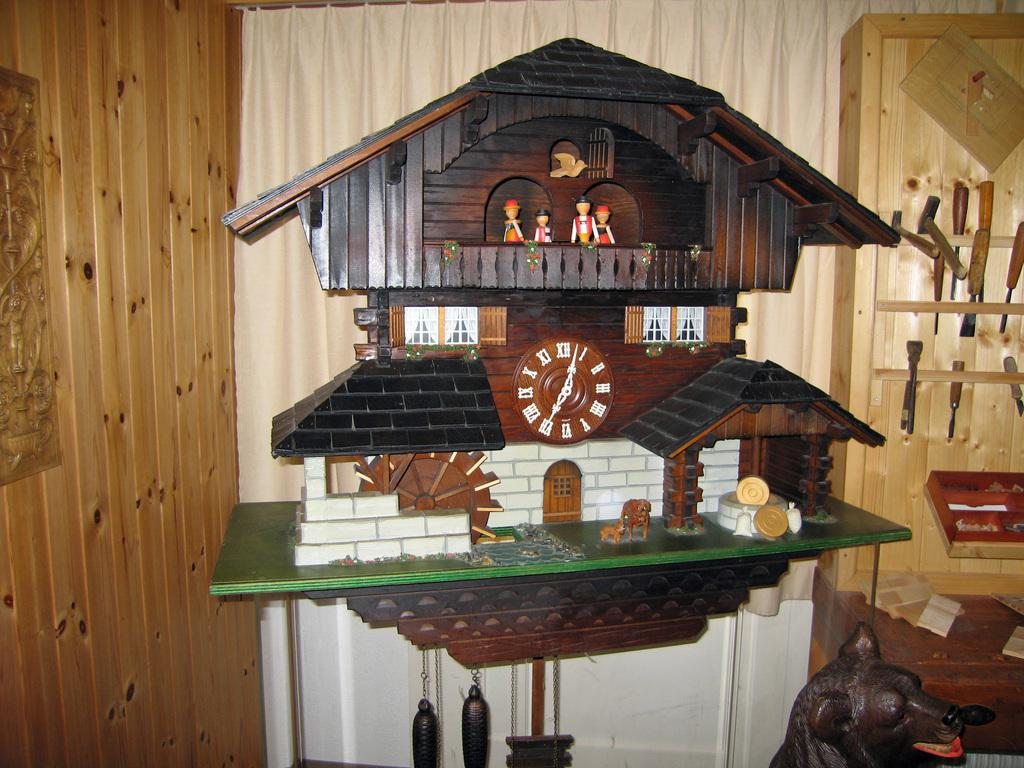<image>
Create a compact narrative representing the image presented. A big wooden chime clock is showing the time of 12:25. 